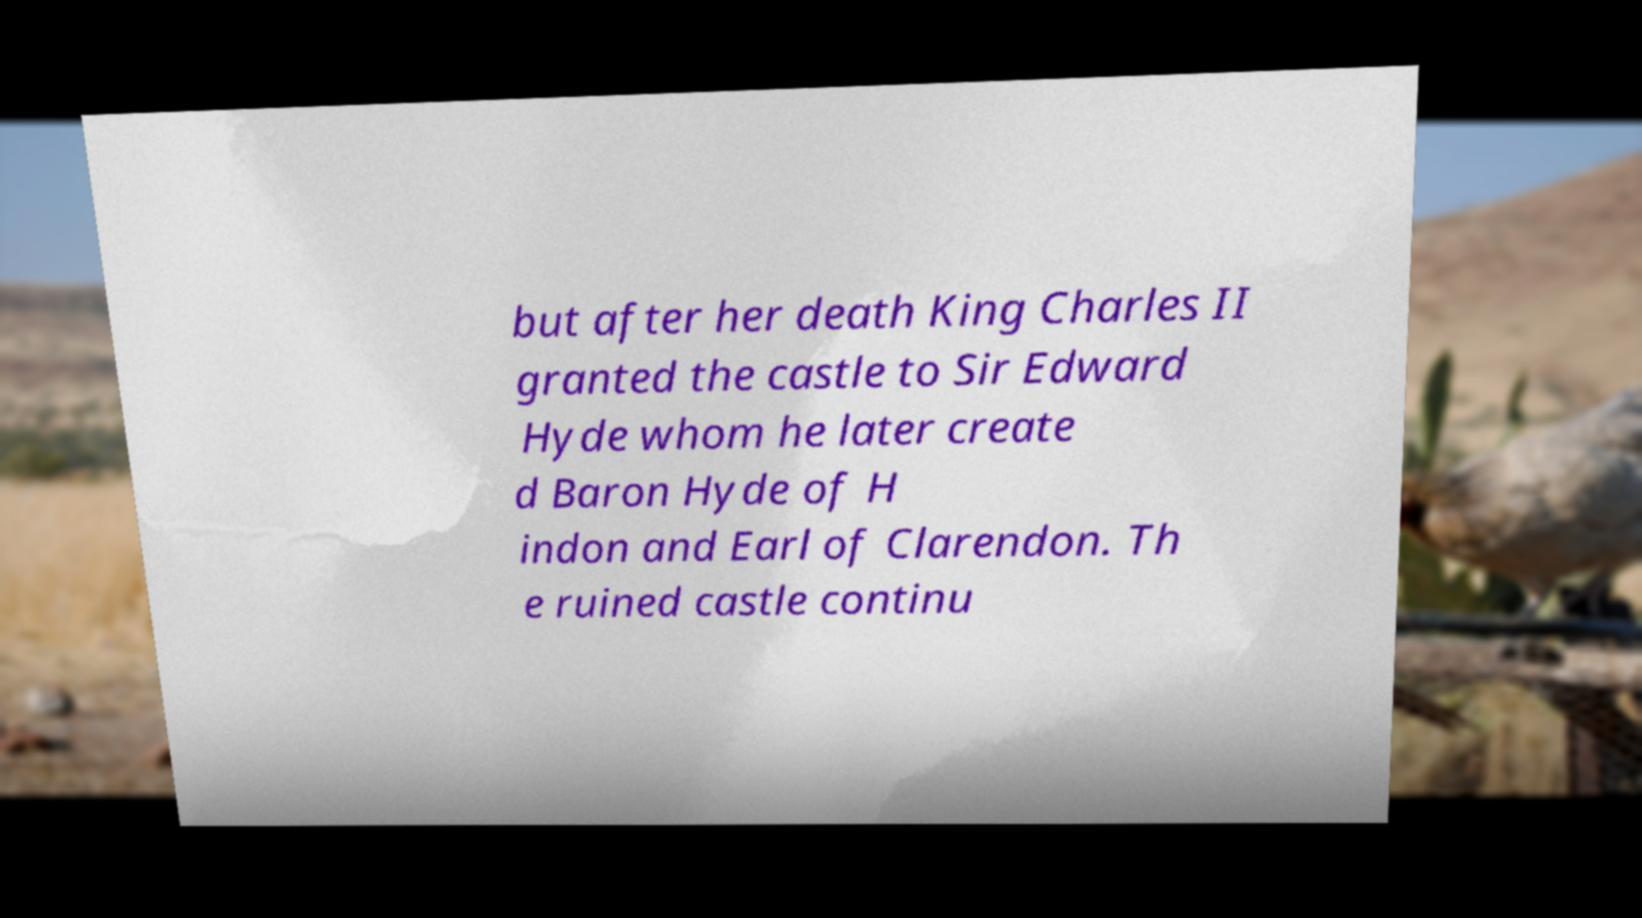Can you read and provide the text displayed in the image?This photo seems to have some interesting text. Can you extract and type it out for me? but after her death King Charles II granted the castle to Sir Edward Hyde whom he later create d Baron Hyde of H indon and Earl of Clarendon. Th e ruined castle continu 